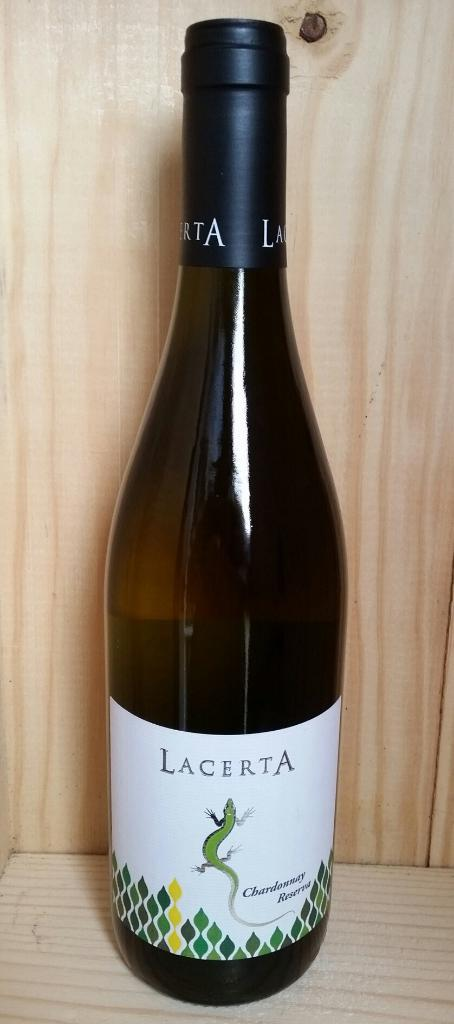<image>
Summarize the visual content of the image. A bottle of Lacerta wine has a salamander on the label. 